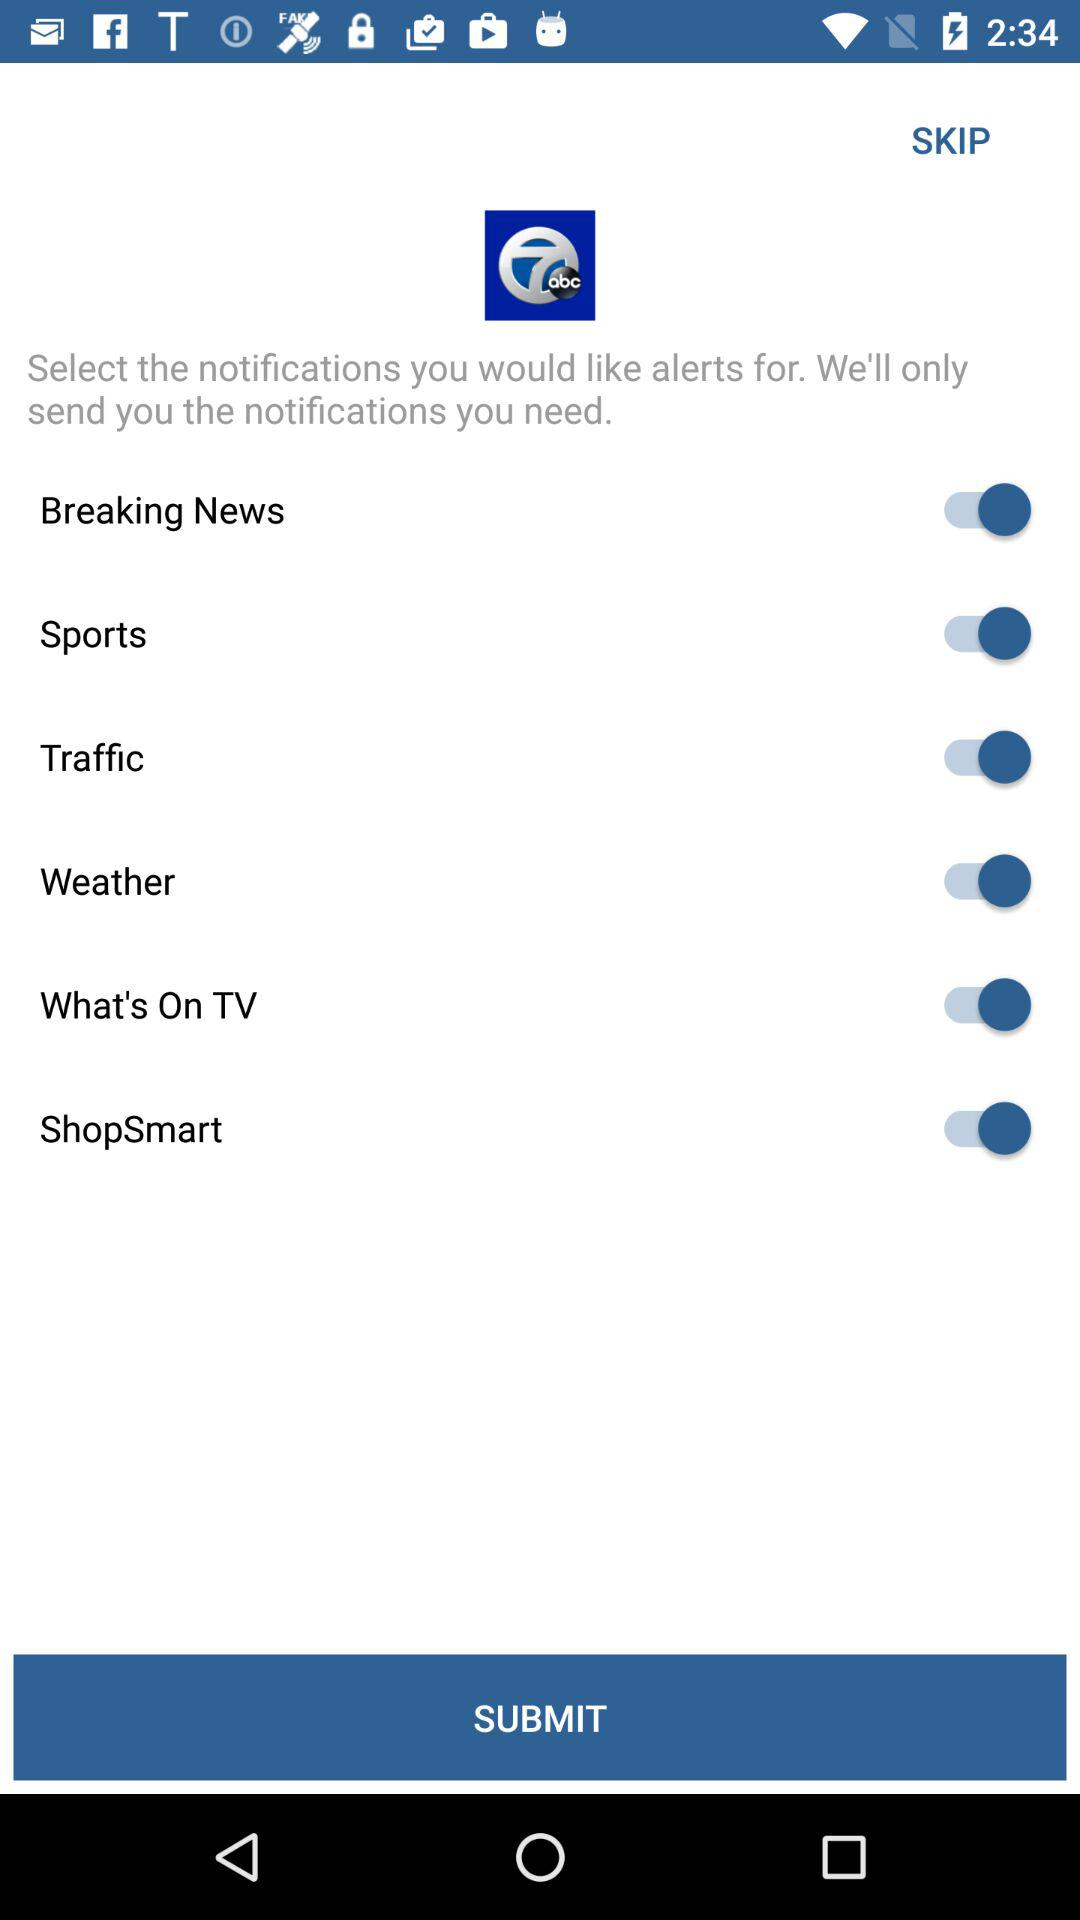What is the status of the weather? The status is on. 